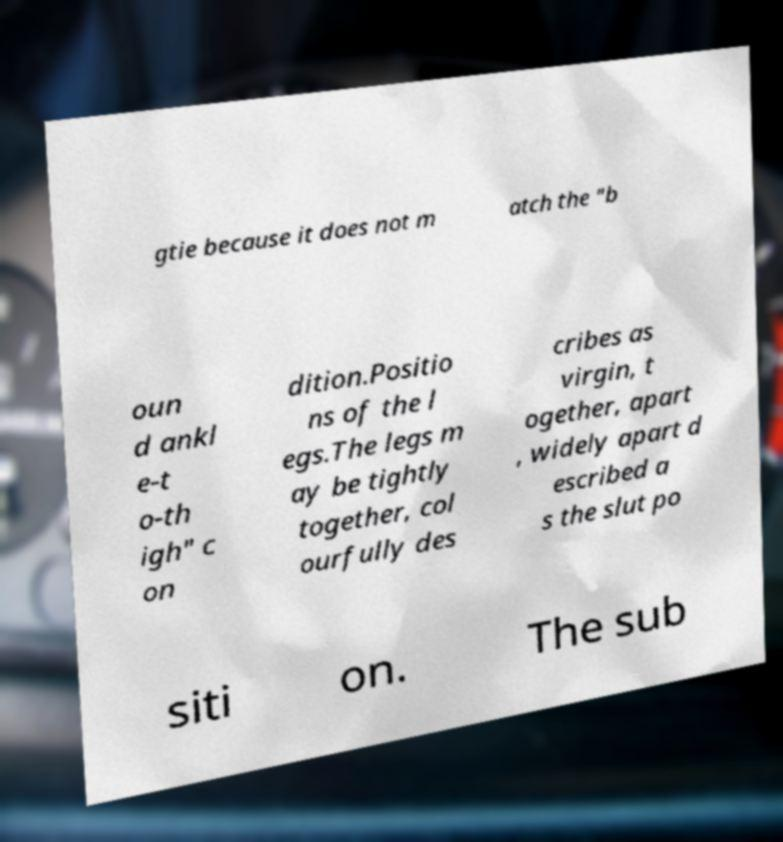Could you extract and type out the text from this image? gtie because it does not m atch the "b oun d ankl e-t o-th igh" c on dition.Positio ns of the l egs.The legs m ay be tightly together, col ourfully des cribes as virgin, t ogether, apart , widely apart d escribed a s the slut po siti on. The sub 